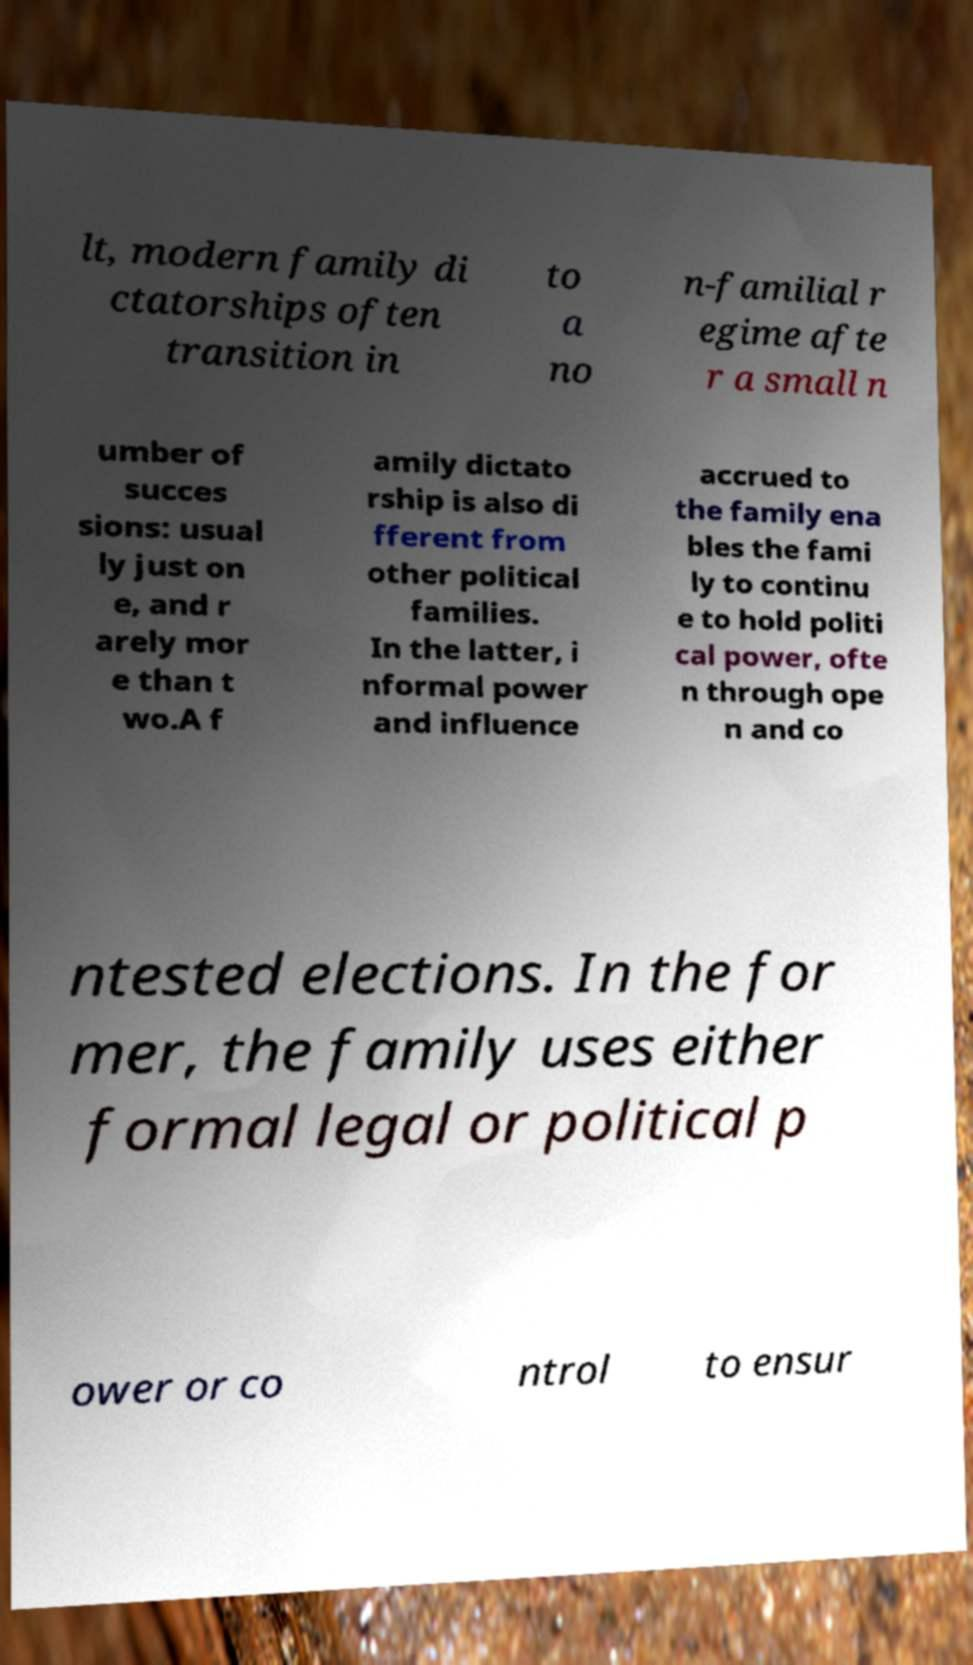For documentation purposes, I need the text within this image transcribed. Could you provide that? lt, modern family di ctatorships often transition in to a no n-familial r egime afte r a small n umber of succes sions: usual ly just on e, and r arely mor e than t wo.A f amily dictato rship is also di fferent from other political families. In the latter, i nformal power and influence accrued to the family ena bles the fami ly to continu e to hold politi cal power, ofte n through ope n and co ntested elections. In the for mer, the family uses either formal legal or political p ower or co ntrol to ensur 